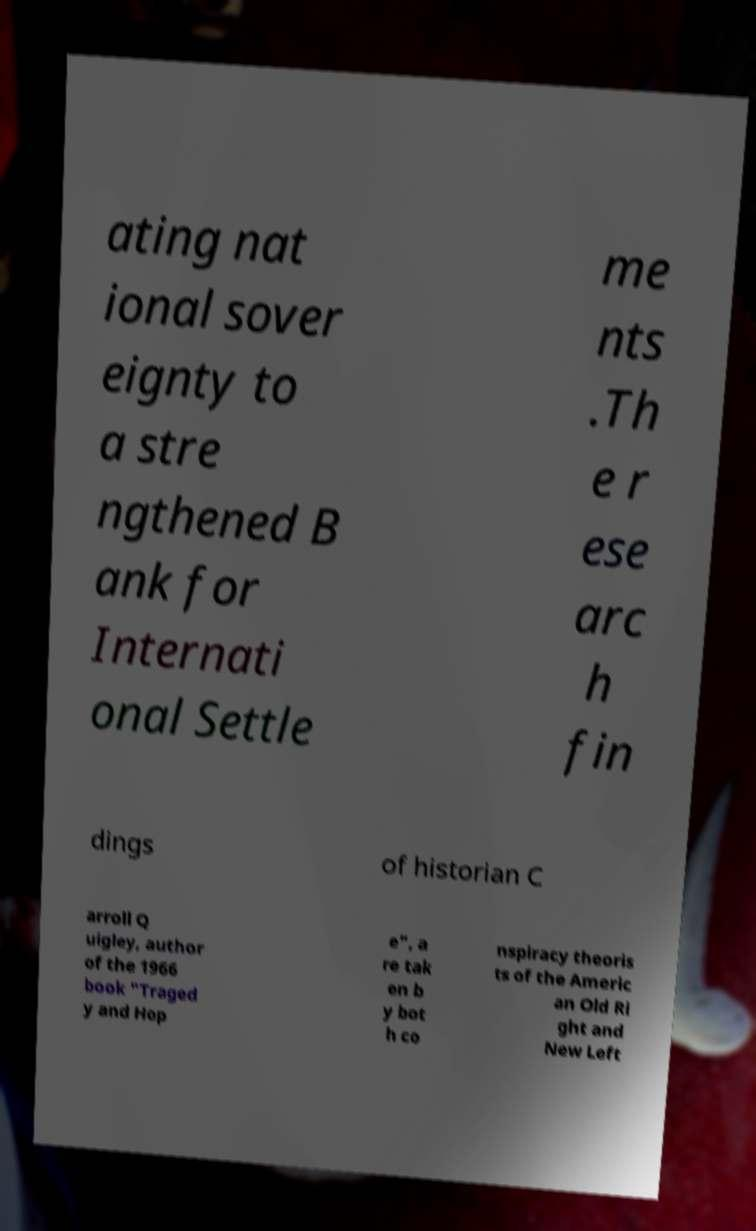There's text embedded in this image that I need extracted. Can you transcribe it verbatim? ating nat ional sover eignty to a stre ngthened B ank for Internati onal Settle me nts .Th e r ese arc h fin dings of historian C arroll Q uigley, author of the 1966 book "Traged y and Hop e", a re tak en b y bot h co nspiracy theoris ts of the Americ an Old Ri ght and New Left 